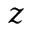<formula> <loc_0><loc_0><loc_500><loc_500>z</formula> 